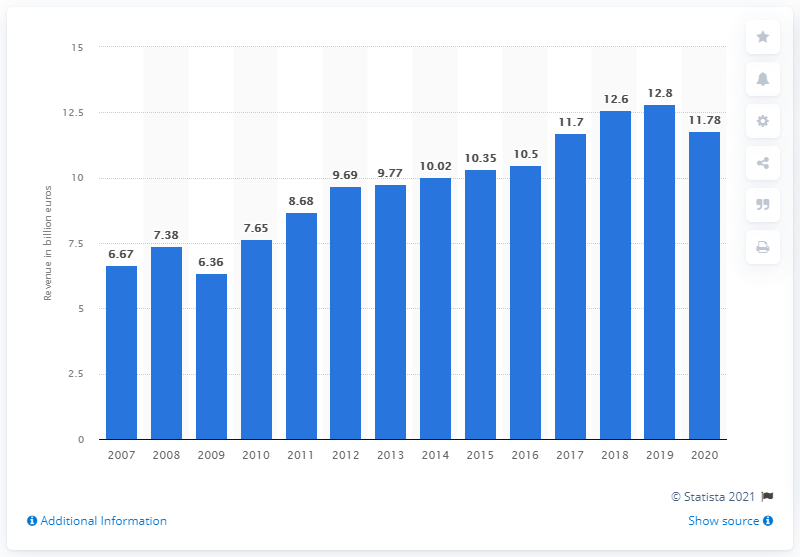Indicate a few pertinent items in this graphic. Brenntag's revenue in 2020 was 11.78 million. 